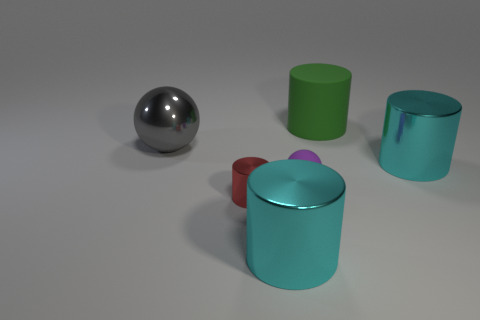Are there fewer tiny red things in front of the small red object than big purple matte things?
Your answer should be very brief. No. The matte thing that is the same size as the red metal cylinder is what color?
Offer a terse response. Purple. How many other tiny objects have the same shape as the gray metal object?
Offer a terse response. 1. The rubber thing in front of the large rubber cylinder is what color?
Give a very brief answer. Purple. How many shiny objects are either purple objects or small cubes?
Give a very brief answer. 0. What number of yellow objects have the same size as the red cylinder?
Offer a very short reply. 0. What is the color of the shiny object that is both in front of the big gray thing and behind the small metal cylinder?
Give a very brief answer. Cyan. What number of objects are either rubber balls or rubber cylinders?
Offer a very short reply. 2. How many large things are either cyan rubber blocks or purple rubber things?
Your response must be concise. 0. Is there any other thing of the same color as the tiny metallic object?
Provide a short and direct response. No. 